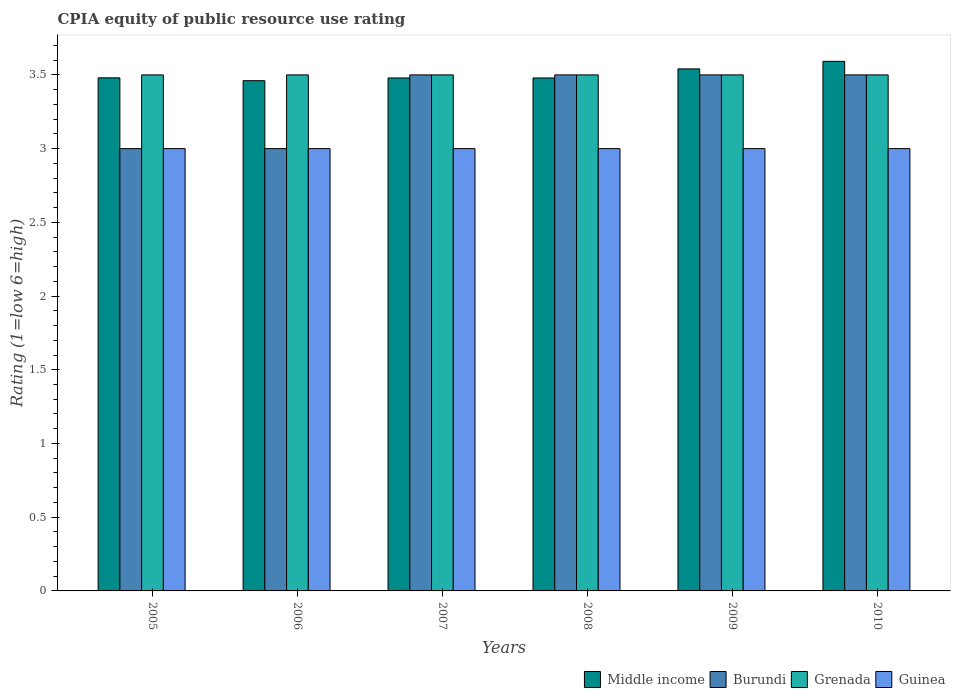Are the number of bars per tick equal to the number of legend labels?
Give a very brief answer. Yes. Are the number of bars on each tick of the X-axis equal?
Give a very brief answer. Yes. How many bars are there on the 3rd tick from the left?
Ensure brevity in your answer.  4. How many bars are there on the 4th tick from the right?
Make the answer very short. 4. In how many cases, is the number of bars for a given year not equal to the number of legend labels?
Provide a succinct answer. 0. What is the CPIA rating in Grenada in 2007?
Ensure brevity in your answer.  3.5. Across all years, what is the maximum CPIA rating in Middle income?
Make the answer very short. 3.59. Across all years, what is the minimum CPIA rating in Burundi?
Offer a very short reply. 3. In which year was the CPIA rating in Middle income maximum?
Offer a very short reply. 2010. What is the total CPIA rating in Middle income in the graph?
Provide a short and direct response. 21.03. What is the difference between the CPIA rating in Middle income in 2008 and the CPIA rating in Burundi in 2009?
Offer a very short reply. -0.02. In the year 2007, what is the difference between the CPIA rating in Burundi and CPIA rating in Middle income?
Your answer should be very brief. 0.02. What is the ratio of the CPIA rating in Guinea in 2006 to that in 2009?
Offer a very short reply. 1. What is the difference between the highest and the lowest CPIA rating in Burundi?
Your response must be concise. 0.5. In how many years, is the CPIA rating in Middle income greater than the average CPIA rating in Middle income taken over all years?
Offer a very short reply. 2. What does the 4th bar from the left in 2007 represents?
Your response must be concise. Guinea. Is it the case that in every year, the sum of the CPIA rating in Guinea and CPIA rating in Grenada is greater than the CPIA rating in Middle income?
Give a very brief answer. Yes. Are all the bars in the graph horizontal?
Keep it short and to the point. No. How many years are there in the graph?
Provide a succinct answer. 6. What is the difference between two consecutive major ticks on the Y-axis?
Your response must be concise. 0.5. Does the graph contain grids?
Provide a succinct answer. No. Where does the legend appear in the graph?
Ensure brevity in your answer.  Bottom right. How are the legend labels stacked?
Make the answer very short. Horizontal. What is the title of the graph?
Your answer should be compact. CPIA equity of public resource use rating. Does "Turkmenistan" appear as one of the legend labels in the graph?
Offer a terse response. No. What is the Rating (1=low 6=high) of Middle income in 2005?
Provide a short and direct response. 3.48. What is the Rating (1=low 6=high) in Grenada in 2005?
Keep it short and to the point. 3.5. What is the Rating (1=low 6=high) in Middle income in 2006?
Keep it short and to the point. 3.46. What is the Rating (1=low 6=high) of Grenada in 2006?
Offer a very short reply. 3.5. What is the Rating (1=low 6=high) of Middle income in 2007?
Give a very brief answer. 3.48. What is the Rating (1=low 6=high) of Middle income in 2008?
Provide a succinct answer. 3.48. What is the Rating (1=low 6=high) of Burundi in 2008?
Offer a terse response. 3.5. What is the Rating (1=low 6=high) of Grenada in 2008?
Keep it short and to the point. 3.5. What is the Rating (1=low 6=high) in Guinea in 2008?
Provide a succinct answer. 3. What is the Rating (1=low 6=high) in Middle income in 2009?
Your response must be concise. 3.54. What is the Rating (1=low 6=high) of Grenada in 2009?
Your answer should be very brief. 3.5. What is the Rating (1=low 6=high) of Middle income in 2010?
Ensure brevity in your answer.  3.59. What is the Rating (1=low 6=high) in Burundi in 2010?
Provide a succinct answer. 3.5. What is the Rating (1=low 6=high) in Grenada in 2010?
Offer a very short reply. 3.5. Across all years, what is the maximum Rating (1=low 6=high) of Middle income?
Give a very brief answer. 3.59. Across all years, what is the minimum Rating (1=low 6=high) in Middle income?
Your response must be concise. 3.46. Across all years, what is the minimum Rating (1=low 6=high) of Burundi?
Your answer should be very brief. 3. Across all years, what is the minimum Rating (1=low 6=high) of Grenada?
Provide a succinct answer. 3.5. What is the total Rating (1=low 6=high) in Middle income in the graph?
Give a very brief answer. 21.03. What is the total Rating (1=low 6=high) of Burundi in the graph?
Ensure brevity in your answer.  20. What is the total Rating (1=low 6=high) of Grenada in the graph?
Your response must be concise. 21. What is the difference between the Rating (1=low 6=high) in Middle income in 2005 and that in 2006?
Offer a very short reply. 0.02. What is the difference between the Rating (1=low 6=high) of Burundi in 2005 and that in 2006?
Your response must be concise. 0. What is the difference between the Rating (1=low 6=high) in Grenada in 2005 and that in 2006?
Keep it short and to the point. 0. What is the difference between the Rating (1=low 6=high) of Middle income in 2005 and that in 2007?
Your response must be concise. 0. What is the difference between the Rating (1=low 6=high) of Burundi in 2005 and that in 2007?
Give a very brief answer. -0.5. What is the difference between the Rating (1=low 6=high) in Guinea in 2005 and that in 2007?
Provide a succinct answer. 0. What is the difference between the Rating (1=low 6=high) in Middle income in 2005 and that in 2008?
Give a very brief answer. 0. What is the difference between the Rating (1=low 6=high) of Guinea in 2005 and that in 2008?
Give a very brief answer. 0. What is the difference between the Rating (1=low 6=high) in Middle income in 2005 and that in 2009?
Your response must be concise. -0.06. What is the difference between the Rating (1=low 6=high) in Middle income in 2005 and that in 2010?
Make the answer very short. -0.11. What is the difference between the Rating (1=low 6=high) in Burundi in 2005 and that in 2010?
Keep it short and to the point. -0.5. What is the difference between the Rating (1=low 6=high) in Grenada in 2005 and that in 2010?
Your answer should be very brief. 0. What is the difference between the Rating (1=low 6=high) of Guinea in 2005 and that in 2010?
Keep it short and to the point. 0. What is the difference between the Rating (1=low 6=high) of Middle income in 2006 and that in 2007?
Your answer should be compact. -0.02. What is the difference between the Rating (1=low 6=high) of Middle income in 2006 and that in 2008?
Offer a very short reply. -0.02. What is the difference between the Rating (1=low 6=high) of Burundi in 2006 and that in 2008?
Keep it short and to the point. -0.5. What is the difference between the Rating (1=low 6=high) of Grenada in 2006 and that in 2008?
Make the answer very short. 0. What is the difference between the Rating (1=low 6=high) in Middle income in 2006 and that in 2009?
Provide a succinct answer. -0.08. What is the difference between the Rating (1=low 6=high) in Burundi in 2006 and that in 2009?
Offer a terse response. -0.5. What is the difference between the Rating (1=low 6=high) in Guinea in 2006 and that in 2009?
Offer a very short reply. 0. What is the difference between the Rating (1=low 6=high) of Middle income in 2006 and that in 2010?
Provide a succinct answer. -0.13. What is the difference between the Rating (1=low 6=high) in Middle income in 2007 and that in 2008?
Provide a succinct answer. 0. What is the difference between the Rating (1=low 6=high) in Middle income in 2007 and that in 2009?
Offer a very short reply. -0.06. What is the difference between the Rating (1=low 6=high) of Burundi in 2007 and that in 2009?
Your answer should be very brief. 0. What is the difference between the Rating (1=low 6=high) in Grenada in 2007 and that in 2009?
Make the answer very short. 0. What is the difference between the Rating (1=low 6=high) of Guinea in 2007 and that in 2009?
Provide a succinct answer. 0. What is the difference between the Rating (1=low 6=high) of Middle income in 2007 and that in 2010?
Provide a succinct answer. -0.11. What is the difference between the Rating (1=low 6=high) in Grenada in 2007 and that in 2010?
Offer a terse response. 0. What is the difference between the Rating (1=low 6=high) in Middle income in 2008 and that in 2009?
Offer a very short reply. -0.06. What is the difference between the Rating (1=low 6=high) in Burundi in 2008 and that in 2009?
Your answer should be very brief. 0. What is the difference between the Rating (1=low 6=high) in Middle income in 2008 and that in 2010?
Your answer should be compact. -0.11. What is the difference between the Rating (1=low 6=high) in Burundi in 2008 and that in 2010?
Make the answer very short. 0. What is the difference between the Rating (1=low 6=high) of Guinea in 2008 and that in 2010?
Offer a terse response. 0. What is the difference between the Rating (1=low 6=high) of Middle income in 2009 and that in 2010?
Keep it short and to the point. -0.05. What is the difference between the Rating (1=low 6=high) of Middle income in 2005 and the Rating (1=low 6=high) of Burundi in 2006?
Ensure brevity in your answer.  0.48. What is the difference between the Rating (1=low 6=high) in Middle income in 2005 and the Rating (1=low 6=high) in Grenada in 2006?
Your answer should be compact. -0.02. What is the difference between the Rating (1=low 6=high) in Middle income in 2005 and the Rating (1=low 6=high) in Guinea in 2006?
Give a very brief answer. 0.48. What is the difference between the Rating (1=low 6=high) of Burundi in 2005 and the Rating (1=low 6=high) of Grenada in 2006?
Give a very brief answer. -0.5. What is the difference between the Rating (1=low 6=high) of Burundi in 2005 and the Rating (1=low 6=high) of Guinea in 2006?
Keep it short and to the point. 0. What is the difference between the Rating (1=low 6=high) in Middle income in 2005 and the Rating (1=low 6=high) in Burundi in 2007?
Provide a short and direct response. -0.02. What is the difference between the Rating (1=low 6=high) of Middle income in 2005 and the Rating (1=low 6=high) of Grenada in 2007?
Your response must be concise. -0.02. What is the difference between the Rating (1=low 6=high) of Middle income in 2005 and the Rating (1=low 6=high) of Guinea in 2007?
Provide a short and direct response. 0.48. What is the difference between the Rating (1=low 6=high) of Burundi in 2005 and the Rating (1=low 6=high) of Grenada in 2007?
Provide a short and direct response. -0.5. What is the difference between the Rating (1=low 6=high) of Grenada in 2005 and the Rating (1=low 6=high) of Guinea in 2007?
Offer a terse response. 0.5. What is the difference between the Rating (1=low 6=high) in Middle income in 2005 and the Rating (1=low 6=high) in Burundi in 2008?
Ensure brevity in your answer.  -0.02. What is the difference between the Rating (1=low 6=high) in Middle income in 2005 and the Rating (1=low 6=high) in Grenada in 2008?
Ensure brevity in your answer.  -0.02. What is the difference between the Rating (1=low 6=high) of Middle income in 2005 and the Rating (1=low 6=high) of Guinea in 2008?
Keep it short and to the point. 0.48. What is the difference between the Rating (1=low 6=high) in Middle income in 2005 and the Rating (1=low 6=high) in Burundi in 2009?
Provide a short and direct response. -0.02. What is the difference between the Rating (1=low 6=high) in Middle income in 2005 and the Rating (1=low 6=high) in Grenada in 2009?
Your answer should be very brief. -0.02. What is the difference between the Rating (1=low 6=high) of Middle income in 2005 and the Rating (1=low 6=high) of Guinea in 2009?
Your answer should be very brief. 0.48. What is the difference between the Rating (1=low 6=high) of Burundi in 2005 and the Rating (1=low 6=high) of Grenada in 2009?
Give a very brief answer. -0.5. What is the difference between the Rating (1=low 6=high) of Grenada in 2005 and the Rating (1=low 6=high) of Guinea in 2009?
Provide a short and direct response. 0.5. What is the difference between the Rating (1=low 6=high) in Middle income in 2005 and the Rating (1=low 6=high) in Burundi in 2010?
Ensure brevity in your answer.  -0.02. What is the difference between the Rating (1=low 6=high) in Middle income in 2005 and the Rating (1=low 6=high) in Grenada in 2010?
Provide a succinct answer. -0.02. What is the difference between the Rating (1=low 6=high) in Middle income in 2005 and the Rating (1=low 6=high) in Guinea in 2010?
Provide a short and direct response. 0.48. What is the difference between the Rating (1=low 6=high) of Burundi in 2005 and the Rating (1=low 6=high) of Guinea in 2010?
Make the answer very short. 0. What is the difference between the Rating (1=low 6=high) of Grenada in 2005 and the Rating (1=low 6=high) of Guinea in 2010?
Provide a short and direct response. 0.5. What is the difference between the Rating (1=low 6=high) of Middle income in 2006 and the Rating (1=low 6=high) of Burundi in 2007?
Keep it short and to the point. -0.04. What is the difference between the Rating (1=low 6=high) of Middle income in 2006 and the Rating (1=low 6=high) of Grenada in 2007?
Provide a succinct answer. -0.04. What is the difference between the Rating (1=low 6=high) of Middle income in 2006 and the Rating (1=low 6=high) of Guinea in 2007?
Make the answer very short. 0.46. What is the difference between the Rating (1=low 6=high) of Burundi in 2006 and the Rating (1=low 6=high) of Grenada in 2007?
Give a very brief answer. -0.5. What is the difference between the Rating (1=low 6=high) in Middle income in 2006 and the Rating (1=low 6=high) in Burundi in 2008?
Provide a succinct answer. -0.04. What is the difference between the Rating (1=low 6=high) of Middle income in 2006 and the Rating (1=low 6=high) of Grenada in 2008?
Offer a very short reply. -0.04. What is the difference between the Rating (1=low 6=high) in Middle income in 2006 and the Rating (1=low 6=high) in Guinea in 2008?
Provide a short and direct response. 0.46. What is the difference between the Rating (1=low 6=high) in Middle income in 2006 and the Rating (1=low 6=high) in Burundi in 2009?
Offer a terse response. -0.04. What is the difference between the Rating (1=low 6=high) in Middle income in 2006 and the Rating (1=low 6=high) in Grenada in 2009?
Provide a succinct answer. -0.04. What is the difference between the Rating (1=low 6=high) in Middle income in 2006 and the Rating (1=low 6=high) in Guinea in 2009?
Ensure brevity in your answer.  0.46. What is the difference between the Rating (1=low 6=high) in Grenada in 2006 and the Rating (1=low 6=high) in Guinea in 2009?
Offer a terse response. 0.5. What is the difference between the Rating (1=low 6=high) of Middle income in 2006 and the Rating (1=low 6=high) of Burundi in 2010?
Provide a short and direct response. -0.04. What is the difference between the Rating (1=low 6=high) in Middle income in 2006 and the Rating (1=low 6=high) in Grenada in 2010?
Offer a very short reply. -0.04. What is the difference between the Rating (1=low 6=high) in Middle income in 2006 and the Rating (1=low 6=high) in Guinea in 2010?
Provide a succinct answer. 0.46. What is the difference between the Rating (1=low 6=high) of Burundi in 2006 and the Rating (1=low 6=high) of Grenada in 2010?
Your answer should be compact. -0.5. What is the difference between the Rating (1=low 6=high) in Grenada in 2006 and the Rating (1=low 6=high) in Guinea in 2010?
Ensure brevity in your answer.  0.5. What is the difference between the Rating (1=low 6=high) of Middle income in 2007 and the Rating (1=low 6=high) of Burundi in 2008?
Ensure brevity in your answer.  -0.02. What is the difference between the Rating (1=low 6=high) in Middle income in 2007 and the Rating (1=low 6=high) in Grenada in 2008?
Ensure brevity in your answer.  -0.02. What is the difference between the Rating (1=low 6=high) of Middle income in 2007 and the Rating (1=low 6=high) of Guinea in 2008?
Offer a very short reply. 0.48. What is the difference between the Rating (1=low 6=high) of Grenada in 2007 and the Rating (1=low 6=high) of Guinea in 2008?
Your answer should be compact. 0.5. What is the difference between the Rating (1=low 6=high) of Middle income in 2007 and the Rating (1=low 6=high) of Burundi in 2009?
Your answer should be compact. -0.02. What is the difference between the Rating (1=low 6=high) of Middle income in 2007 and the Rating (1=low 6=high) of Grenada in 2009?
Make the answer very short. -0.02. What is the difference between the Rating (1=low 6=high) of Middle income in 2007 and the Rating (1=low 6=high) of Guinea in 2009?
Give a very brief answer. 0.48. What is the difference between the Rating (1=low 6=high) of Grenada in 2007 and the Rating (1=low 6=high) of Guinea in 2009?
Your response must be concise. 0.5. What is the difference between the Rating (1=low 6=high) in Middle income in 2007 and the Rating (1=low 6=high) in Burundi in 2010?
Your response must be concise. -0.02. What is the difference between the Rating (1=low 6=high) of Middle income in 2007 and the Rating (1=low 6=high) of Grenada in 2010?
Offer a very short reply. -0.02. What is the difference between the Rating (1=low 6=high) in Middle income in 2007 and the Rating (1=low 6=high) in Guinea in 2010?
Offer a very short reply. 0.48. What is the difference between the Rating (1=low 6=high) in Burundi in 2007 and the Rating (1=low 6=high) in Grenada in 2010?
Your answer should be compact. 0. What is the difference between the Rating (1=low 6=high) in Burundi in 2007 and the Rating (1=low 6=high) in Guinea in 2010?
Provide a succinct answer. 0.5. What is the difference between the Rating (1=low 6=high) in Middle income in 2008 and the Rating (1=low 6=high) in Burundi in 2009?
Ensure brevity in your answer.  -0.02. What is the difference between the Rating (1=low 6=high) of Middle income in 2008 and the Rating (1=low 6=high) of Grenada in 2009?
Your response must be concise. -0.02. What is the difference between the Rating (1=low 6=high) in Middle income in 2008 and the Rating (1=low 6=high) in Guinea in 2009?
Make the answer very short. 0.48. What is the difference between the Rating (1=low 6=high) in Grenada in 2008 and the Rating (1=low 6=high) in Guinea in 2009?
Ensure brevity in your answer.  0.5. What is the difference between the Rating (1=low 6=high) in Middle income in 2008 and the Rating (1=low 6=high) in Burundi in 2010?
Provide a succinct answer. -0.02. What is the difference between the Rating (1=low 6=high) of Middle income in 2008 and the Rating (1=low 6=high) of Grenada in 2010?
Provide a succinct answer. -0.02. What is the difference between the Rating (1=low 6=high) of Middle income in 2008 and the Rating (1=low 6=high) of Guinea in 2010?
Make the answer very short. 0.48. What is the difference between the Rating (1=low 6=high) of Burundi in 2008 and the Rating (1=low 6=high) of Grenada in 2010?
Your answer should be very brief. 0. What is the difference between the Rating (1=low 6=high) of Burundi in 2008 and the Rating (1=low 6=high) of Guinea in 2010?
Offer a terse response. 0.5. What is the difference between the Rating (1=low 6=high) in Grenada in 2008 and the Rating (1=low 6=high) in Guinea in 2010?
Give a very brief answer. 0.5. What is the difference between the Rating (1=low 6=high) in Middle income in 2009 and the Rating (1=low 6=high) in Burundi in 2010?
Your answer should be compact. 0.04. What is the difference between the Rating (1=low 6=high) of Middle income in 2009 and the Rating (1=low 6=high) of Grenada in 2010?
Your response must be concise. 0.04. What is the difference between the Rating (1=low 6=high) in Middle income in 2009 and the Rating (1=low 6=high) in Guinea in 2010?
Make the answer very short. 0.54. What is the difference between the Rating (1=low 6=high) of Burundi in 2009 and the Rating (1=low 6=high) of Grenada in 2010?
Give a very brief answer. 0. What is the average Rating (1=low 6=high) in Middle income per year?
Offer a terse response. 3.51. What is the average Rating (1=low 6=high) of Grenada per year?
Make the answer very short. 3.5. In the year 2005, what is the difference between the Rating (1=low 6=high) in Middle income and Rating (1=low 6=high) in Burundi?
Provide a short and direct response. 0.48. In the year 2005, what is the difference between the Rating (1=low 6=high) in Middle income and Rating (1=low 6=high) in Grenada?
Your answer should be compact. -0.02. In the year 2005, what is the difference between the Rating (1=low 6=high) of Middle income and Rating (1=low 6=high) of Guinea?
Offer a terse response. 0.48. In the year 2005, what is the difference between the Rating (1=low 6=high) of Burundi and Rating (1=low 6=high) of Guinea?
Make the answer very short. 0. In the year 2006, what is the difference between the Rating (1=low 6=high) of Middle income and Rating (1=low 6=high) of Burundi?
Your answer should be compact. 0.46. In the year 2006, what is the difference between the Rating (1=low 6=high) of Middle income and Rating (1=low 6=high) of Grenada?
Ensure brevity in your answer.  -0.04. In the year 2006, what is the difference between the Rating (1=low 6=high) of Middle income and Rating (1=low 6=high) of Guinea?
Your response must be concise. 0.46. In the year 2006, what is the difference between the Rating (1=low 6=high) in Burundi and Rating (1=low 6=high) in Grenada?
Provide a short and direct response. -0.5. In the year 2007, what is the difference between the Rating (1=low 6=high) in Middle income and Rating (1=low 6=high) in Burundi?
Offer a very short reply. -0.02. In the year 2007, what is the difference between the Rating (1=low 6=high) of Middle income and Rating (1=low 6=high) of Grenada?
Make the answer very short. -0.02. In the year 2007, what is the difference between the Rating (1=low 6=high) in Middle income and Rating (1=low 6=high) in Guinea?
Offer a terse response. 0.48. In the year 2007, what is the difference between the Rating (1=low 6=high) in Burundi and Rating (1=low 6=high) in Grenada?
Your answer should be compact. 0. In the year 2007, what is the difference between the Rating (1=low 6=high) of Burundi and Rating (1=low 6=high) of Guinea?
Your answer should be very brief. 0.5. In the year 2008, what is the difference between the Rating (1=low 6=high) of Middle income and Rating (1=low 6=high) of Burundi?
Your answer should be compact. -0.02. In the year 2008, what is the difference between the Rating (1=low 6=high) of Middle income and Rating (1=low 6=high) of Grenada?
Provide a short and direct response. -0.02. In the year 2008, what is the difference between the Rating (1=low 6=high) in Middle income and Rating (1=low 6=high) in Guinea?
Give a very brief answer. 0.48. In the year 2008, what is the difference between the Rating (1=low 6=high) in Burundi and Rating (1=low 6=high) in Guinea?
Give a very brief answer. 0.5. In the year 2008, what is the difference between the Rating (1=low 6=high) of Grenada and Rating (1=low 6=high) of Guinea?
Your response must be concise. 0.5. In the year 2009, what is the difference between the Rating (1=low 6=high) in Middle income and Rating (1=low 6=high) in Burundi?
Provide a short and direct response. 0.04. In the year 2009, what is the difference between the Rating (1=low 6=high) in Middle income and Rating (1=low 6=high) in Grenada?
Your answer should be very brief. 0.04. In the year 2009, what is the difference between the Rating (1=low 6=high) of Middle income and Rating (1=low 6=high) of Guinea?
Ensure brevity in your answer.  0.54. In the year 2009, what is the difference between the Rating (1=low 6=high) in Burundi and Rating (1=low 6=high) in Guinea?
Your answer should be very brief. 0.5. In the year 2010, what is the difference between the Rating (1=low 6=high) in Middle income and Rating (1=low 6=high) in Burundi?
Keep it short and to the point. 0.09. In the year 2010, what is the difference between the Rating (1=low 6=high) in Middle income and Rating (1=low 6=high) in Grenada?
Offer a terse response. 0.09. In the year 2010, what is the difference between the Rating (1=low 6=high) in Middle income and Rating (1=low 6=high) in Guinea?
Your response must be concise. 0.59. In the year 2010, what is the difference between the Rating (1=low 6=high) of Burundi and Rating (1=low 6=high) of Guinea?
Offer a terse response. 0.5. In the year 2010, what is the difference between the Rating (1=low 6=high) of Grenada and Rating (1=low 6=high) of Guinea?
Give a very brief answer. 0.5. What is the ratio of the Rating (1=low 6=high) of Middle income in 2005 to that in 2006?
Your response must be concise. 1.01. What is the ratio of the Rating (1=low 6=high) of Burundi in 2005 to that in 2006?
Make the answer very short. 1. What is the ratio of the Rating (1=low 6=high) in Guinea in 2005 to that in 2006?
Make the answer very short. 1. What is the ratio of the Rating (1=low 6=high) of Middle income in 2005 to that in 2007?
Keep it short and to the point. 1. What is the ratio of the Rating (1=low 6=high) of Burundi in 2005 to that in 2007?
Provide a short and direct response. 0.86. What is the ratio of the Rating (1=low 6=high) in Middle income in 2005 to that in 2009?
Ensure brevity in your answer.  0.98. What is the ratio of the Rating (1=low 6=high) in Grenada in 2005 to that in 2009?
Your answer should be very brief. 1. What is the ratio of the Rating (1=low 6=high) in Guinea in 2005 to that in 2009?
Make the answer very short. 1. What is the ratio of the Rating (1=low 6=high) in Middle income in 2005 to that in 2010?
Give a very brief answer. 0.97. What is the ratio of the Rating (1=low 6=high) of Grenada in 2006 to that in 2007?
Offer a terse response. 1. What is the ratio of the Rating (1=low 6=high) of Middle income in 2006 to that in 2008?
Keep it short and to the point. 0.99. What is the ratio of the Rating (1=low 6=high) in Middle income in 2006 to that in 2009?
Your answer should be compact. 0.98. What is the ratio of the Rating (1=low 6=high) of Grenada in 2006 to that in 2009?
Provide a short and direct response. 1. What is the ratio of the Rating (1=low 6=high) of Guinea in 2006 to that in 2009?
Your answer should be compact. 1. What is the ratio of the Rating (1=low 6=high) of Middle income in 2006 to that in 2010?
Your answer should be very brief. 0.96. What is the ratio of the Rating (1=low 6=high) of Guinea in 2006 to that in 2010?
Give a very brief answer. 1. What is the ratio of the Rating (1=low 6=high) in Burundi in 2007 to that in 2008?
Your answer should be compact. 1. What is the ratio of the Rating (1=low 6=high) of Middle income in 2007 to that in 2009?
Ensure brevity in your answer.  0.98. What is the ratio of the Rating (1=low 6=high) in Grenada in 2007 to that in 2009?
Your answer should be very brief. 1. What is the ratio of the Rating (1=low 6=high) in Guinea in 2007 to that in 2009?
Your answer should be compact. 1. What is the ratio of the Rating (1=low 6=high) in Middle income in 2007 to that in 2010?
Your answer should be compact. 0.97. What is the ratio of the Rating (1=low 6=high) of Burundi in 2007 to that in 2010?
Ensure brevity in your answer.  1. What is the ratio of the Rating (1=low 6=high) in Grenada in 2007 to that in 2010?
Your answer should be compact. 1. What is the ratio of the Rating (1=low 6=high) in Middle income in 2008 to that in 2009?
Make the answer very short. 0.98. What is the ratio of the Rating (1=low 6=high) in Burundi in 2008 to that in 2009?
Provide a short and direct response. 1. What is the ratio of the Rating (1=low 6=high) in Grenada in 2008 to that in 2009?
Offer a very short reply. 1. What is the ratio of the Rating (1=low 6=high) of Middle income in 2008 to that in 2010?
Your response must be concise. 0.97. What is the ratio of the Rating (1=low 6=high) in Burundi in 2008 to that in 2010?
Provide a succinct answer. 1. What is the ratio of the Rating (1=low 6=high) in Middle income in 2009 to that in 2010?
Provide a succinct answer. 0.99. What is the ratio of the Rating (1=low 6=high) in Burundi in 2009 to that in 2010?
Your answer should be compact. 1. What is the difference between the highest and the second highest Rating (1=low 6=high) of Middle income?
Keep it short and to the point. 0.05. What is the difference between the highest and the second highest Rating (1=low 6=high) in Burundi?
Provide a short and direct response. 0. What is the difference between the highest and the second highest Rating (1=low 6=high) in Grenada?
Ensure brevity in your answer.  0. What is the difference between the highest and the lowest Rating (1=low 6=high) in Middle income?
Provide a short and direct response. 0.13. What is the difference between the highest and the lowest Rating (1=low 6=high) of Burundi?
Offer a terse response. 0.5. What is the difference between the highest and the lowest Rating (1=low 6=high) of Grenada?
Ensure brevity in your answer.  0. 